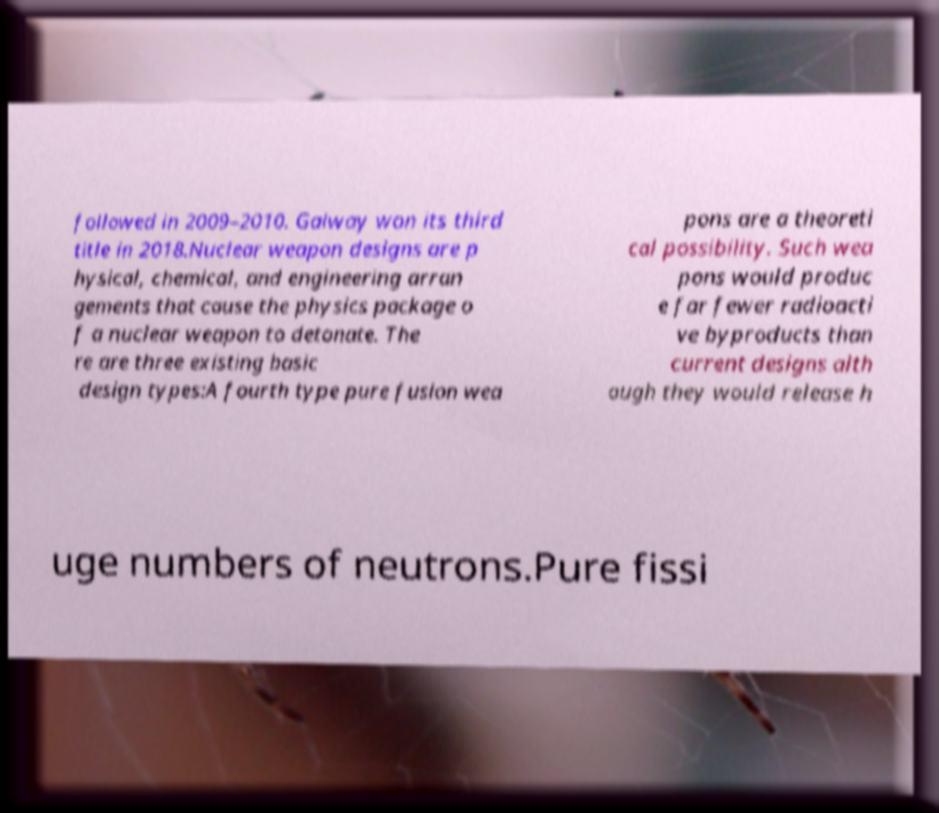Please read and relay the text visible in this image. What does it say? followed in 2009–2010. Galway won its third title in 2018.Nuclear weapon designs are p hysical, chemical, and engineering arran gements that cause the physics package o f a nuclear weapon to detonate. The re are three existing basic design types:A fourth type pure fusion wea pons are a theoreti cal possibility. Such wea pons would produc e far fewer radioacti ve byproducts than current designs alth ough they would release h uge numbers of neutrons.Pure fissi 